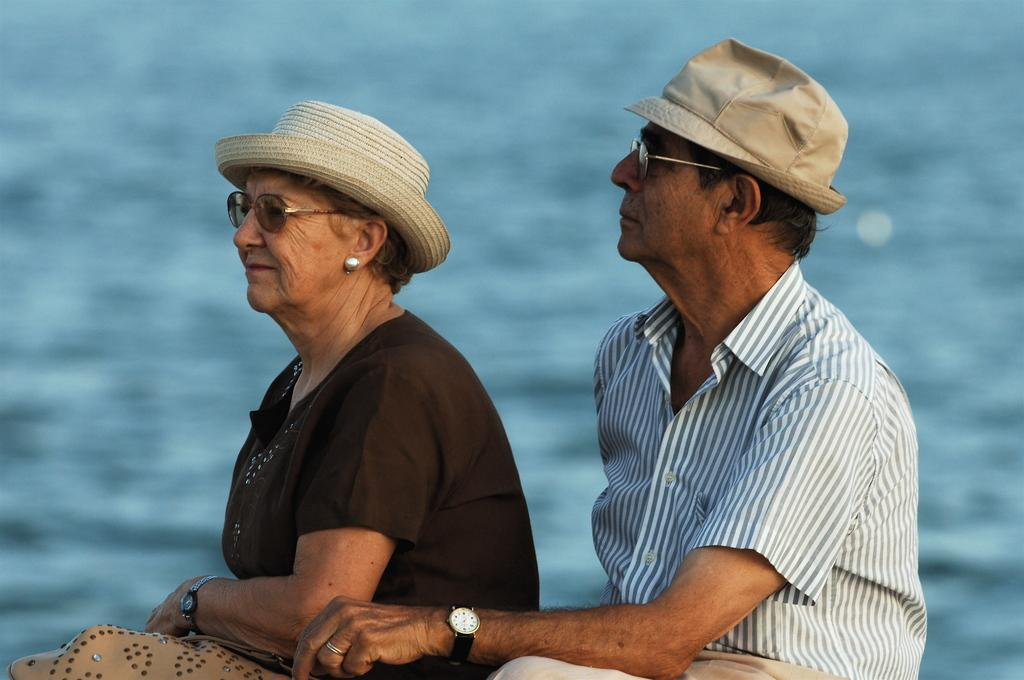How many people are in the image? There are two people in the image. What are the two people doing in the image? The two people are sitting. What type of light can be seen coming from the giants in the image? There are no giants present in the image, so there is no light coming from them. 